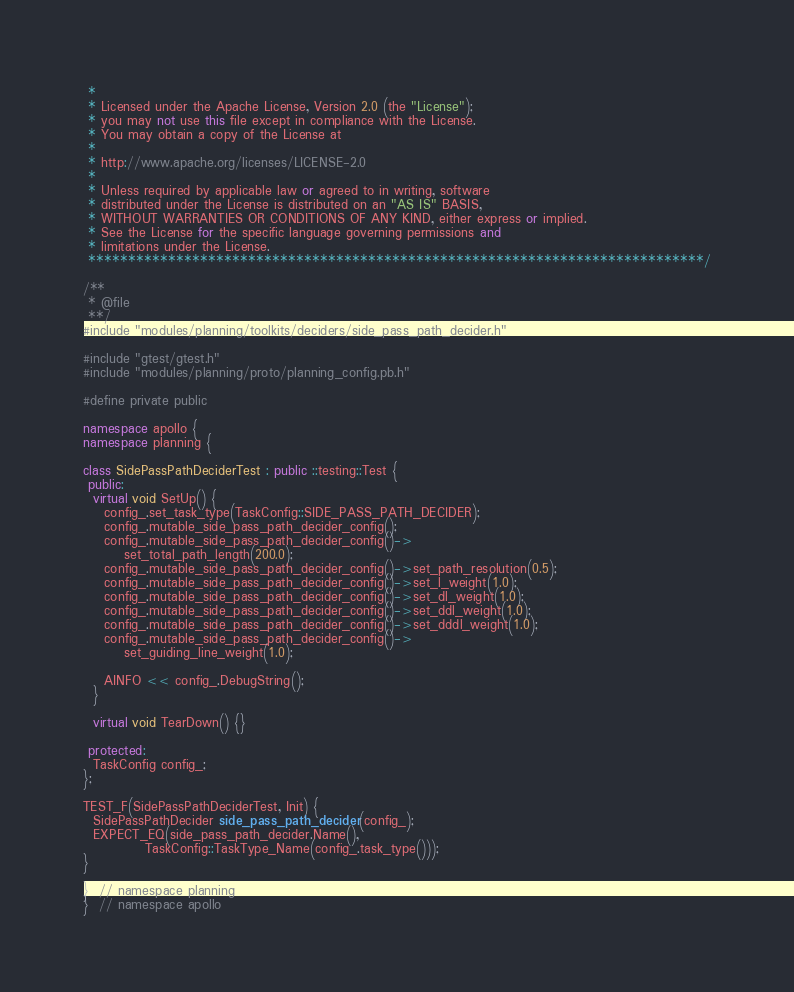Convert code to text. <code><loc_0><loc_0><loc_500><loc_500><_C++_> *
 * Licensed under the Apache License, Version 2.0 (the "License");
 * you may not use this file except in compliance with the License.
 * You may obtain a copy of the License at
 *
 * http://www.apache.org/licenses/LICENSE-2.0
 *
 * Unless required by applicable law or agreed to in writing, software
 * distributed under the License is distributed on an "AS IS" BASIS,
 * WITHOUT WARRANTIES OR CONDITIONS OF ANY KIND, either express or implied.
 * See the License for the specific language governing permissions and
 * limitations under the License.
 *****************************************************************************/

/**
 * @file
 **/
#include "modules/planning/toolkits/deciders/side_pass_path_decider.h"

#include "gtest/gtest.h"
#include "modules/planning/proto/planning_config.pb.h"

#define private public

namespace apollo {
namespace planning {

class SidePassPathDeciderTest : public ::testing::Test {
 public:
  virtual void SetUp() {
    config_.set_task_type(TaskConfig::SIDE_PASS_PATH_DECIDER);
    config_.mutable_side_pass_path_decider_config();
    config_.mutable_side_pass_path_decider_config()->
        set_total_path_length(200.0);
    config_.mutable_side_pass_path_decider_config()->set_path_resolution(0.5);
    config_.mutable_side_pass_path_decider_config()->set_l_weight(1.0);
    config_.mutable_side_pass_path_decider_config()->set_dl_weight(1.0);
    config_.mutable_side_pass_path_decider_config()->set_ddl_weight(1.0);
    config_.mutable_side_pass_path_decider_config()->set_dddl_weight(1.0);
    config_.mutable_side_pass_path_decider_config()->
        set_guiding_line_weight(1.0);

    AINFO << config_.DebugString();
  }

  virtual void TearDown() {}

 protected:
  TaskConfig config_;
};

TEST_F(SidePassPathDeciderTest, Init) {
  SidePassPathDecider side_pass_path_decider(config_);
  EXPECT_EQ(side_pass_path_decider.Name(),
            TaskConfig::TaskType_Name(config_.task_type()));
}

}  // namespace planning
}  // namespace apollo
</code> 